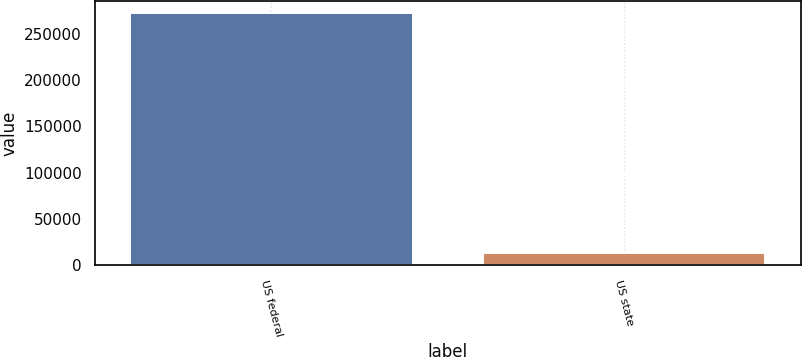<chart> <loc_0><loc_0><loc_500><loc_500><bar_chart><fcel>US federal<fcel>US state<nl><fcel>272289<fcel>13940<nl></chart> 